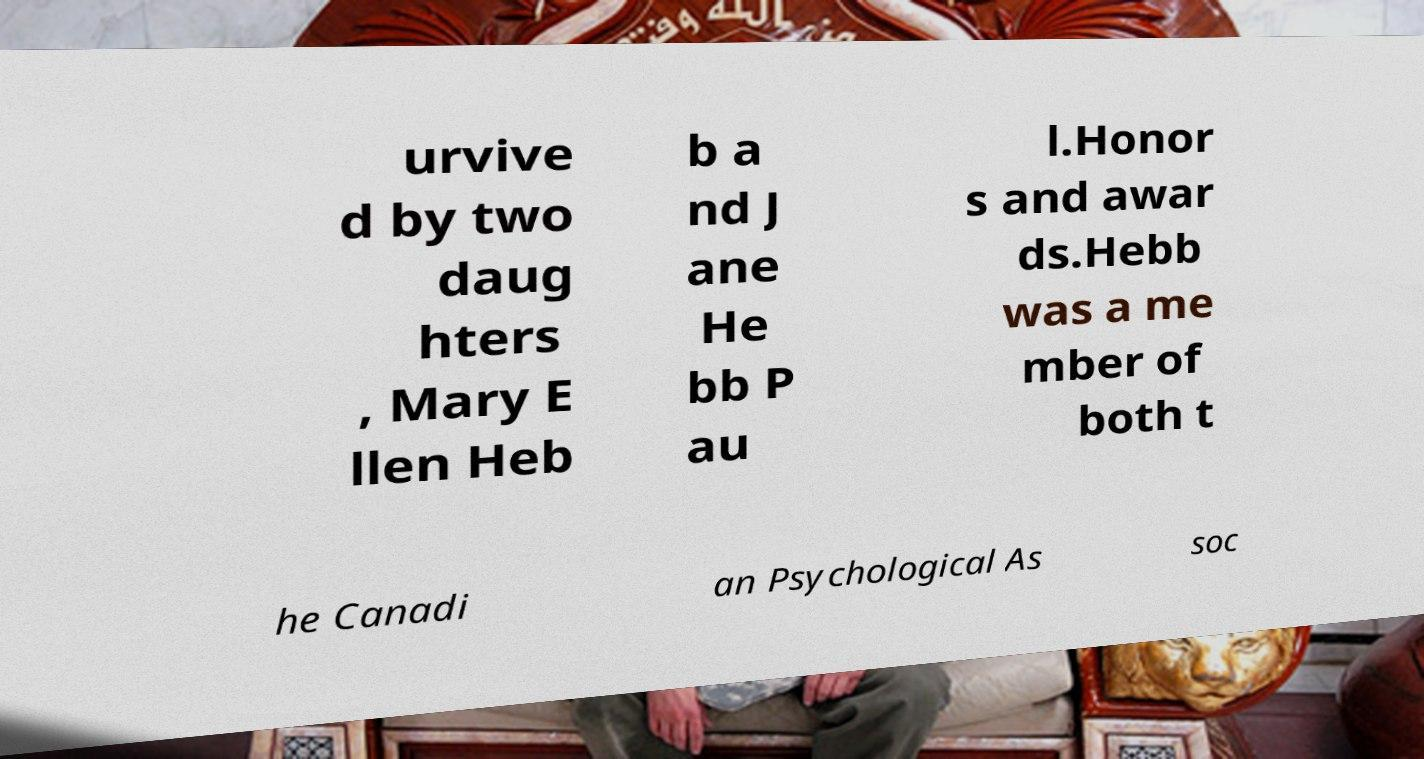Please identify and transcribe the text found in this image. urvive d by two daug hters , Mary E llen Heb b a nd J ane He bb P au l.Honor s and awar ds.Hebb was a me mber of both t he Canadi an Psychological As soc 